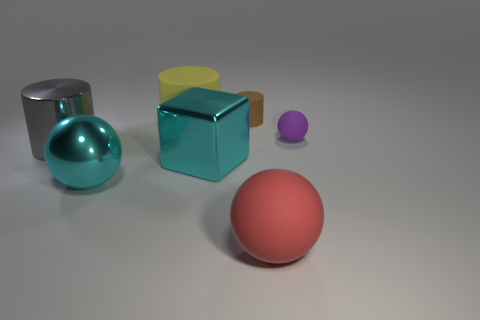Are there any large cubes that have the same color as the tiny matte ball?
Keep it short and to the point. No. There is a cyan metallic object that is behind the large cyan sphere; are there any big yellow rubber objects in front of it?
Provide a succinct answer. No. Are there any small balls that have the same material as the cyan block?
Your response must be concise. No. There is a large object that is in front of the big cyan metallic thing to the left of the big yellow rubber object; what is it made of?
Ensure brevity in your answer.  Rubber. The thing that is both in front of the yellow rubber object and behind the gray thing is made of what material?
Offer a very short reply. Rubber. Are there the same number of large yellow matte cylinders that are on the right side of the red sphere and small yellow cylinders?
Give a very brief answer. Yes. What number of big red rubber things have the same shape as the tiny purple object?
Ensure brevity in your answer.  1. There is a rubber object that is on the left side of the small rubber object that is on the left side of the tiny matte object on the right side of the small brown thing; how big is it?
Make the answer very short. Large. Is the ball behind the large gray cylinder made of the same material as the big cyan sphere?
Your response must be concise. No. Is the number of small purple things that are left of the tiny ball the same as the number of yellow matte cylinders that are in front of the cyan cube?
Keep it short and to the point. Yes. 